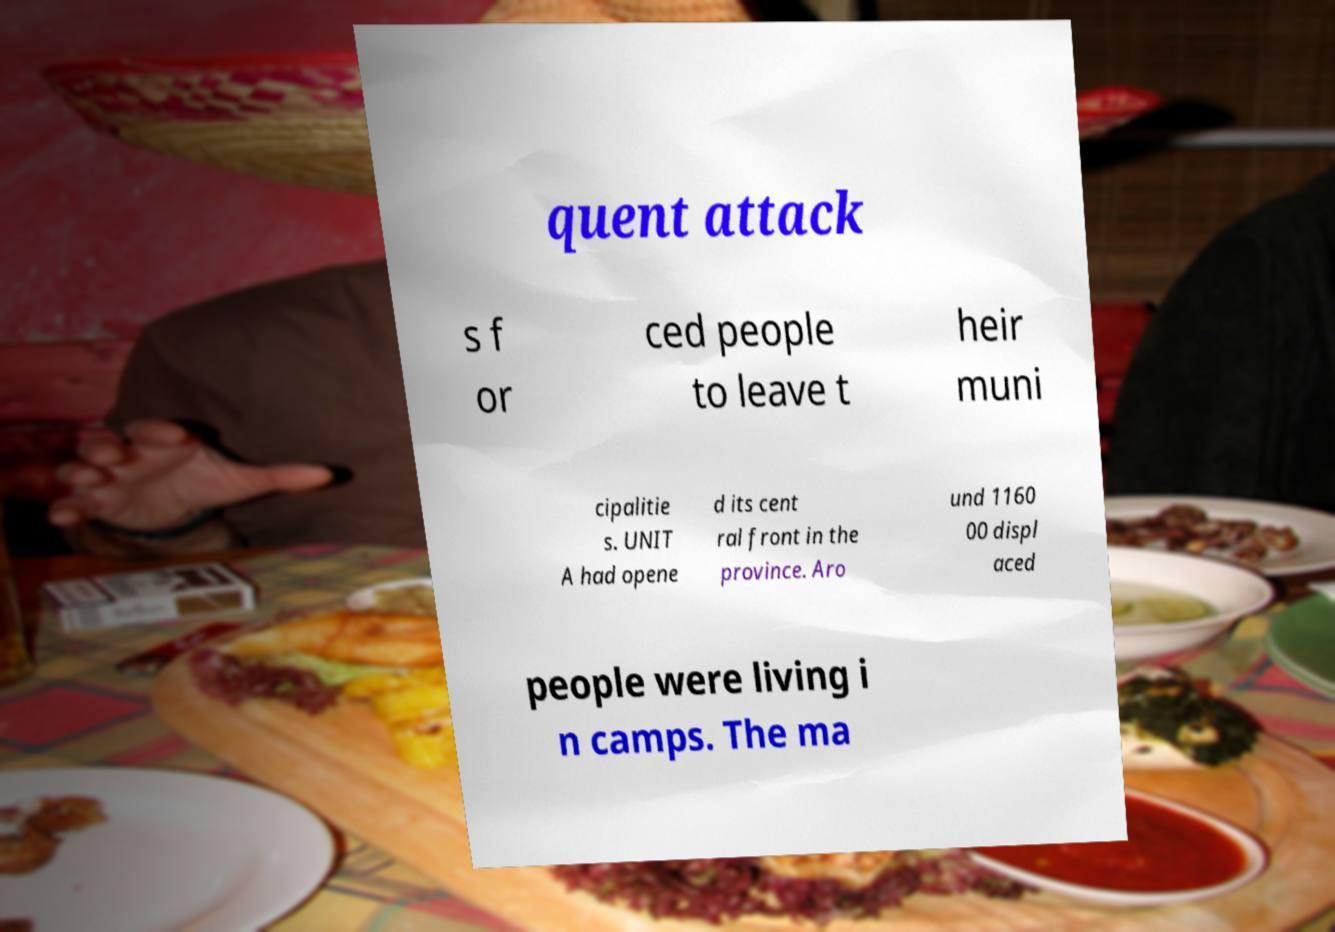What messages or text are displayed in this image? I need them in a readable, typed format. quent attack s f or ced people to leave t heir muni cipalitie s. UNIT A had opene d its cent ral front in the province. Aro und 1160 00 displ aced people were living i n camps. The ma 